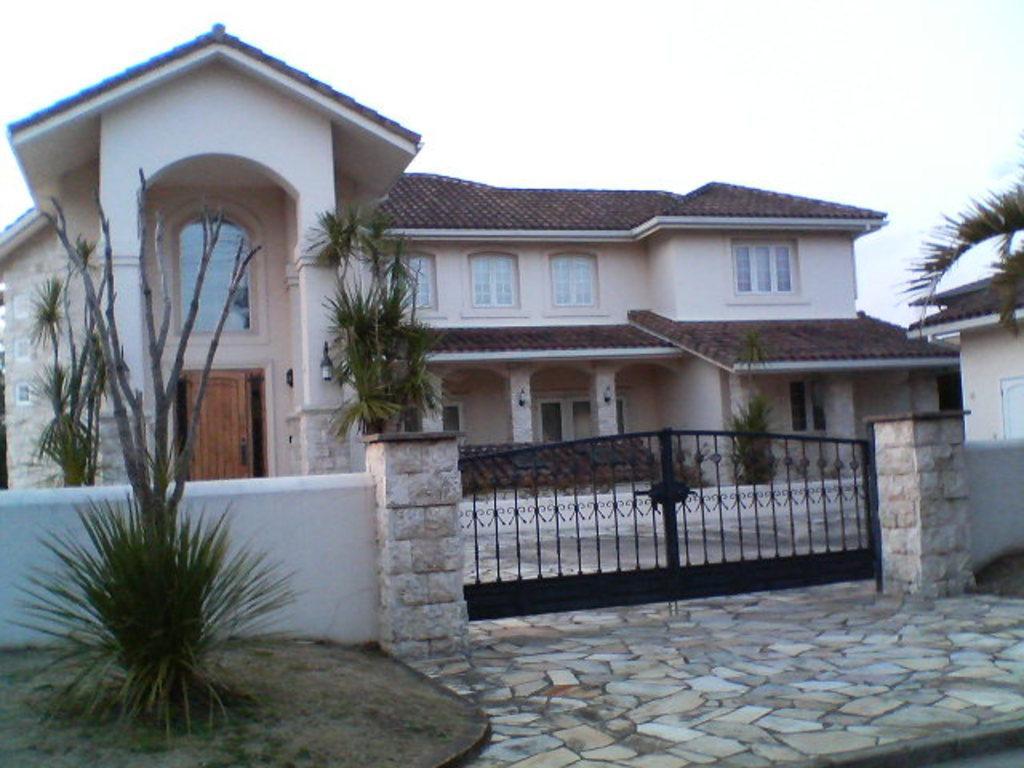Can you describe this image briefly? In this image, we can see a house. We can see the ground. We can see some grass, plants and trees. We can also see the wall with a black colored gate. We can see the sky. 